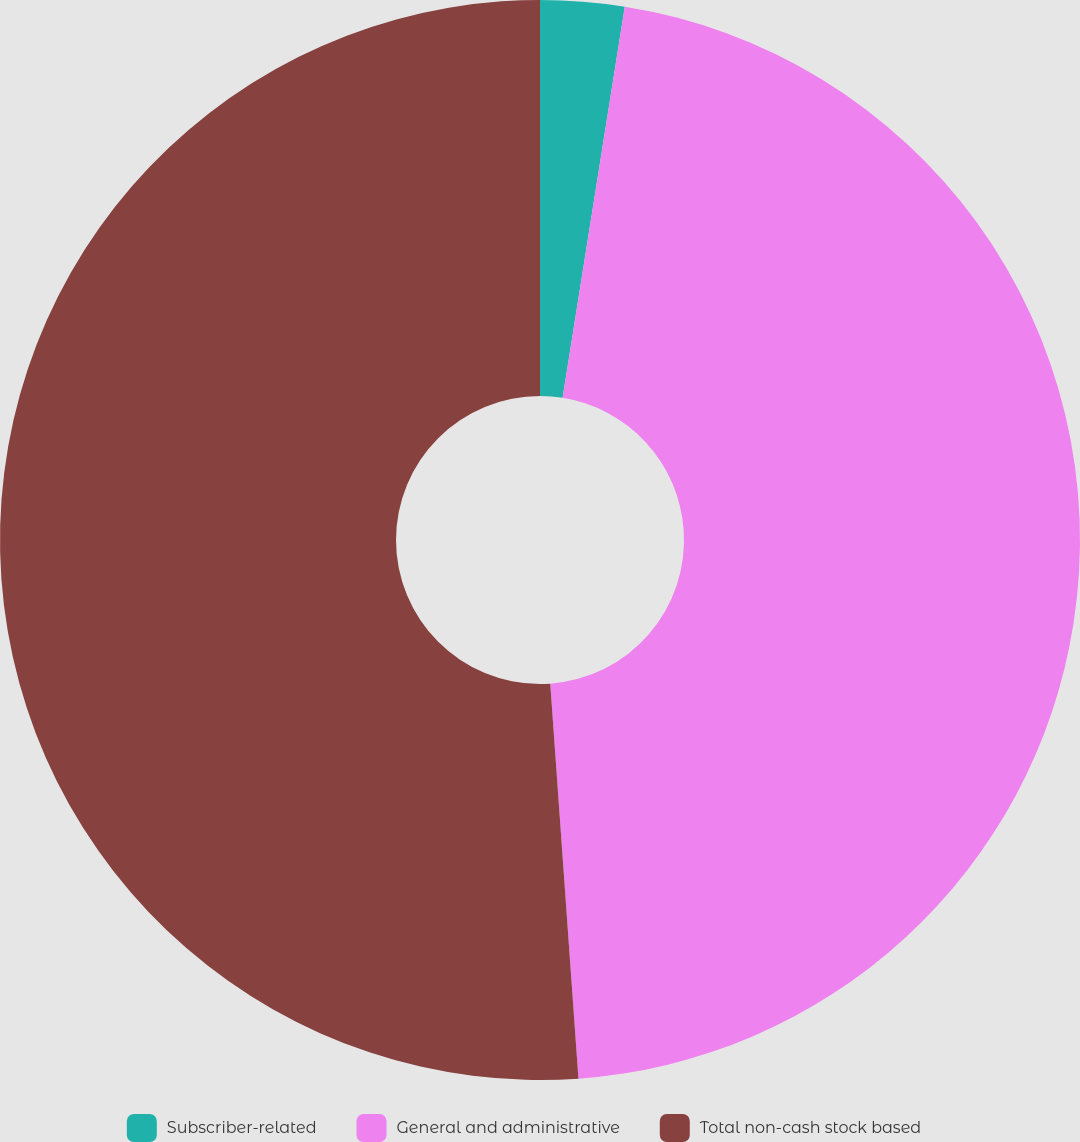<chart> <loc_0><loc_0><loc_500><loc_500><pie_chart><fcel>Subscriber-related<fcel>General and administrative<fcel>Total non-cash stock based<nl><fcel>2.51%<fcel>46.36%<fcel>51.14%<nl></chart> 